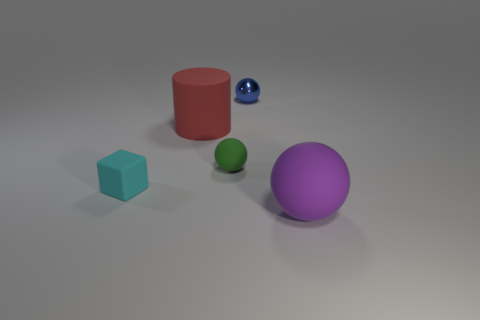Add 2 tiny green rubber spheres. How many objects exist? 7 Subtract all cylinders. How many objects are left? 4 Subtract 0 brown cylinders. How many objects are left? 5 Subtract all small objects. Subtract all large spheres. How many objects are left? 1 Add 3 rubber cubes. How many rubber cubes are left? 4 Add 1 metal objects. How many metal objects exist? 2 